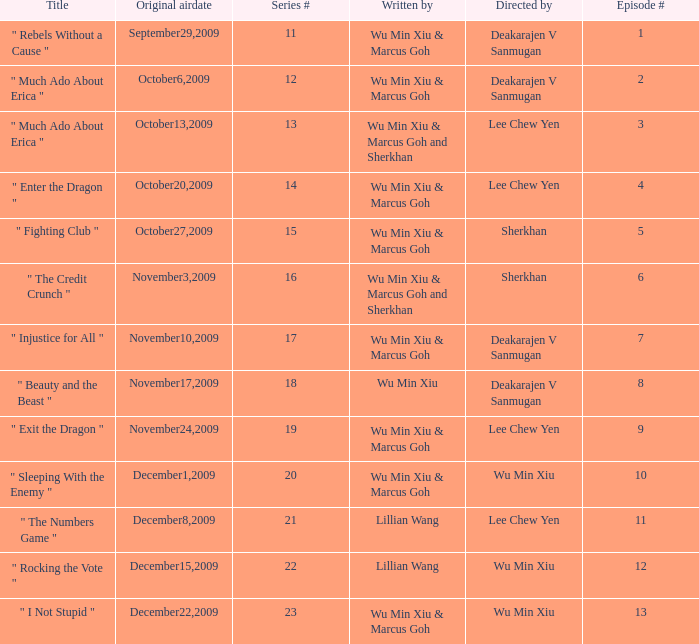What is the episode number for series 17? 7.0. 